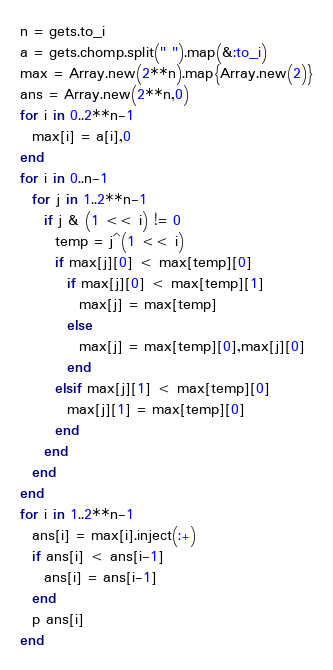<code> <loc_0><loc_0><loc_500><loc_500><_Ruby_>n = gets.to_i
a = gets.chomp.split(" ").map(&:to_i)
max = Array.new(2**n).map{Array.new(2)}
ans = Array.new(2**n,0)
for i in 0..2**n-1
  max[i] = a[i],0
end
for i in 0..n-1
  for j in 1..2**n-1
    if j & (1 << i) != 0
      temp = j^(1 << i)
      if max[j][0] < max[temp][0]
        if max[j][0] < max[temp][1]
          max[j] = max[temp]
        else
          max[j] = max[temp][0],max[j][0]
        end
      elsif max[j][1] < max[temp][0]
        max[j][1] = max[temp][0]
      end
    end
  end
end
for i in 1..2**n-1
  ans[i] = max[i].inject(:+)
  if ans[i] < ans[i-1]
    ans[i] = ans[i-1]
  end
  p ans[i]
end</code> 